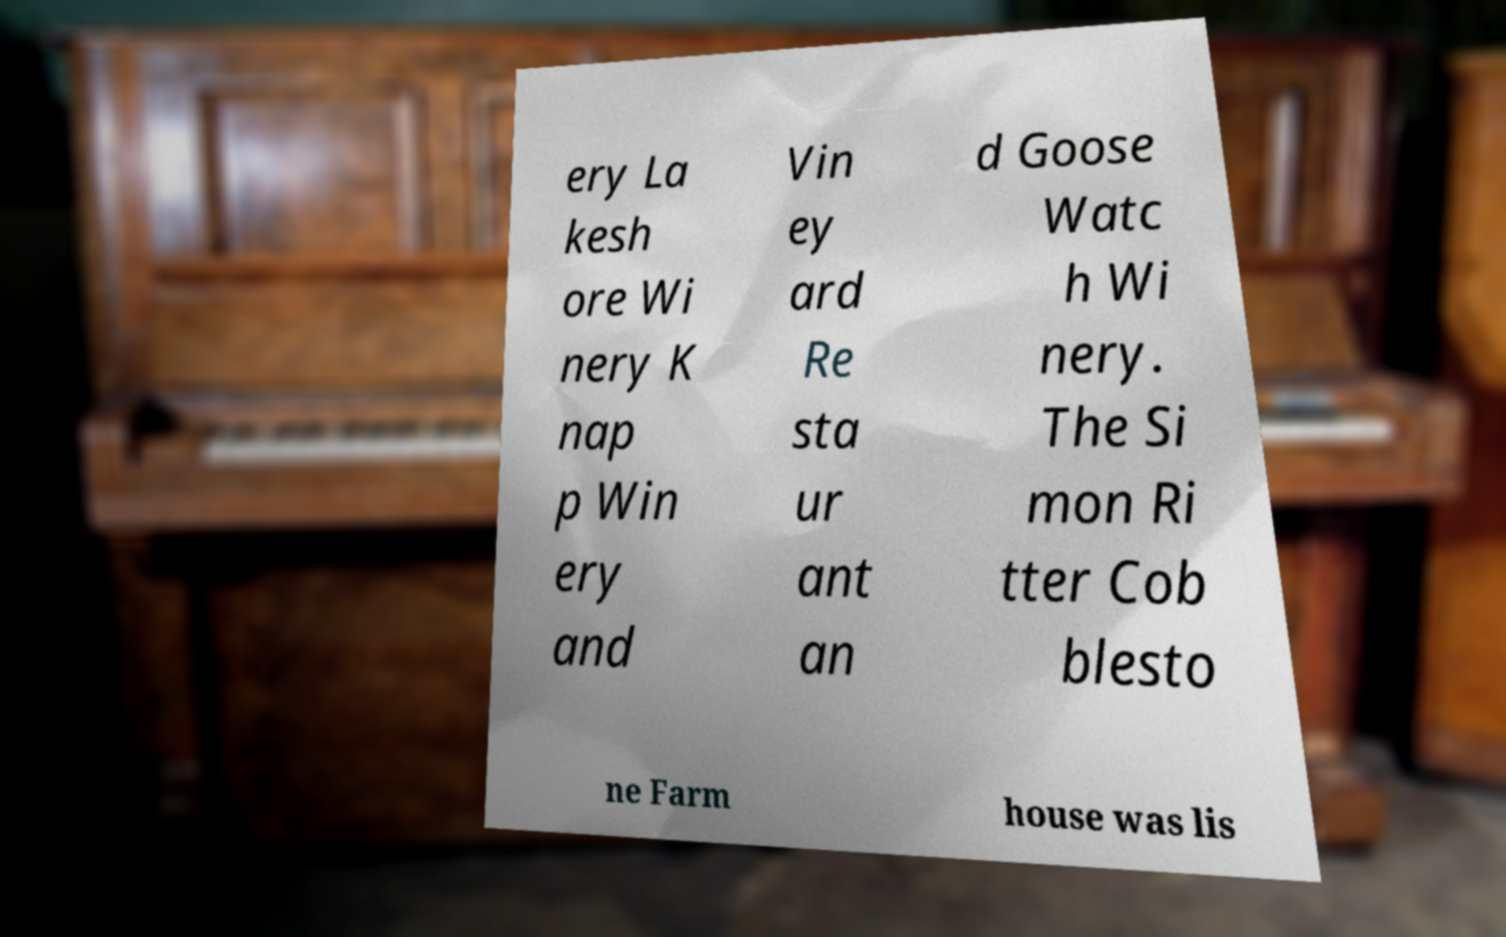Can you accurately transcribe the text from the provided image for me? ery La kesh ore Wi nery K nap p Win ery and Vin ey ard Re sta ur ant an d Goose Watc h Wi nery. The Si mon Ri tter Cob blesto ne Farm house was lis 